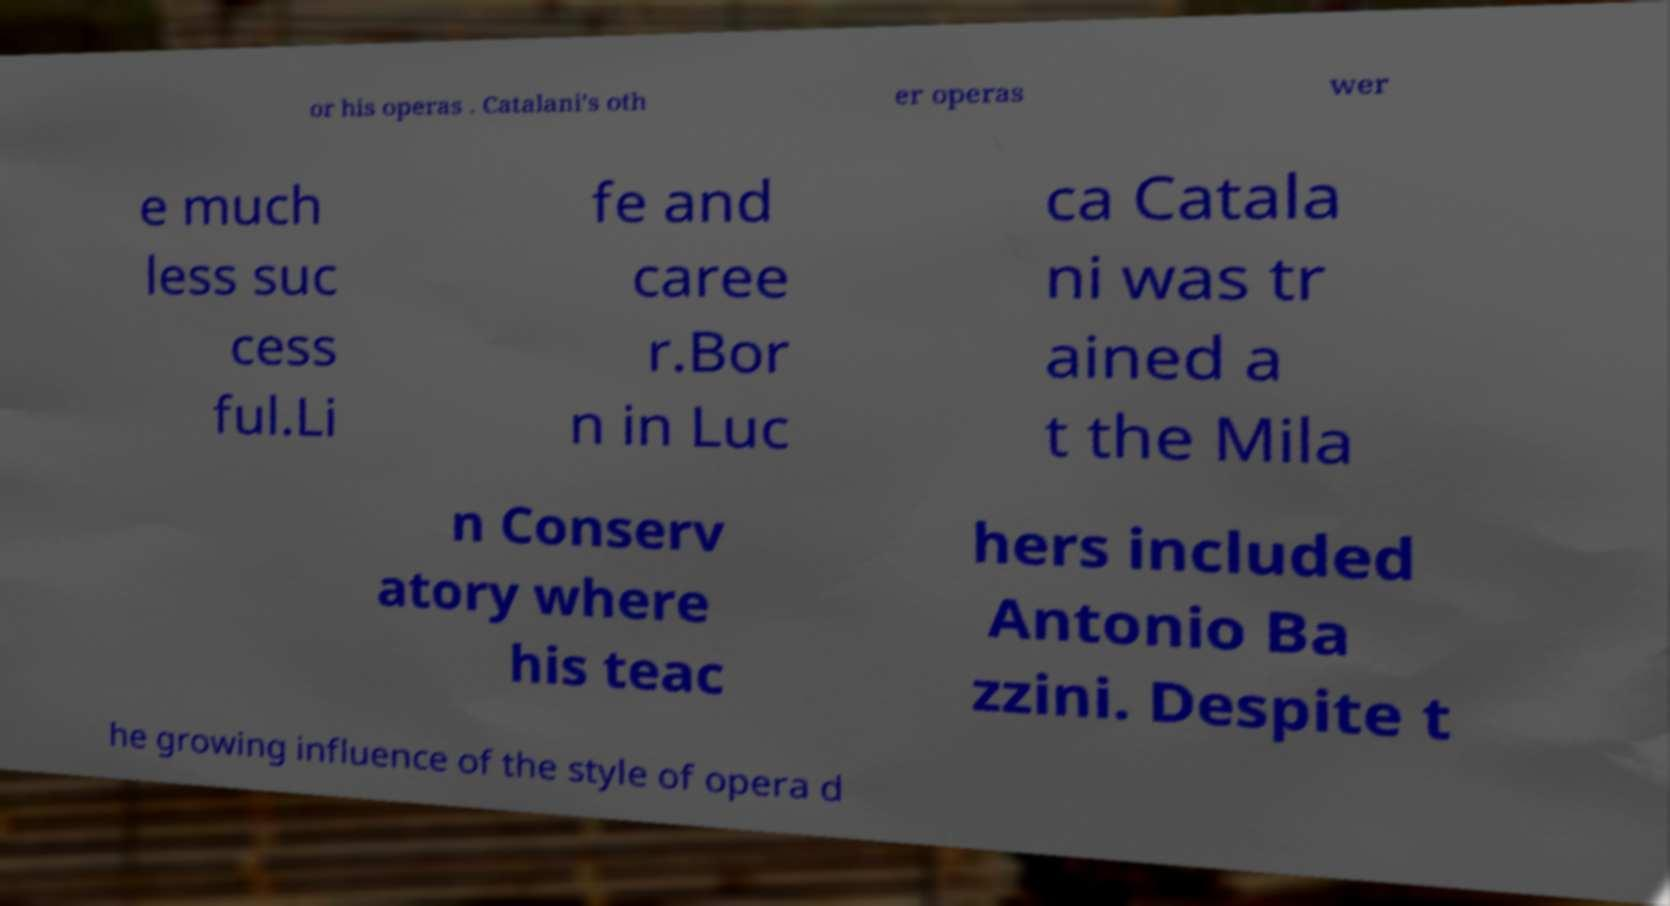Can you accurately transcribe the text from the provided image for me? or his operas . Catalani's oth er operas wer e much less suc cess ful.Li fe and caree r.Bor n in Luc ca Catala ni was tr ained a t the Mila n Conserv atory where his teac hers included Antonio Ba zzini. Despite t he growing influence of the style of opera d 